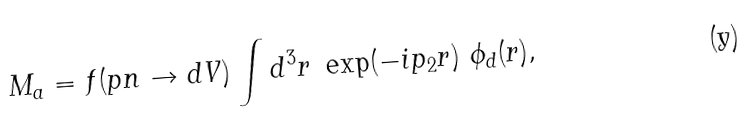<formula> <loc_0><loc_0><loc_500><loc_500>M _ { a } = f ( p n \to d V ) \int d ^ { 3 } { r } \ \exp ( - i { p _ { 2 } } { r } ) \ \phi _ { d } ( { r } ) ,</formula> 